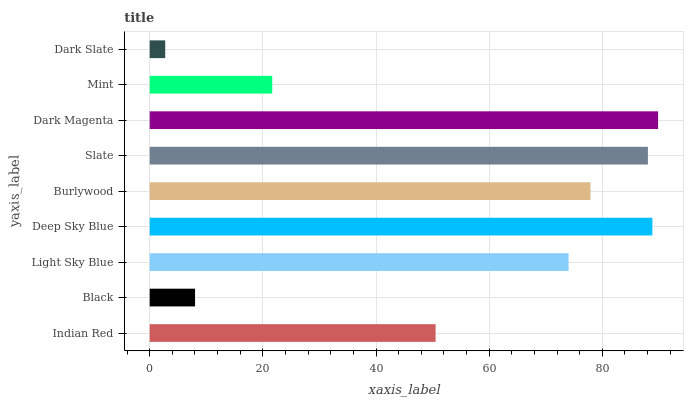Is Dark Slate the minimum?
Answer yes or no. Yes. Is Dark Magenta the maximum?
Answer yes or no. Yes. Is Black the minimum?
Answer yes or no. No. Is Black the maximum?
Answer yes or no. No. Is Indian Red greater than Black?
Answer yes or no. Yes. Is Black less than Indian Red?
Answer yes or no. Yes. Is Black greater than Indian Red?
Answer yes or no. No. Is Indian Red less than Black?
Answer yes or no. No. Is Light Sky Blue the high median?
Answer yes or no. Yes. Is Light Sky Blue the low median?
Answer yes or no. Yes. Is Burlywood the high median?
Answer yes or no. No. Is Dark Slate the low median?
Answer yes or no. No. 